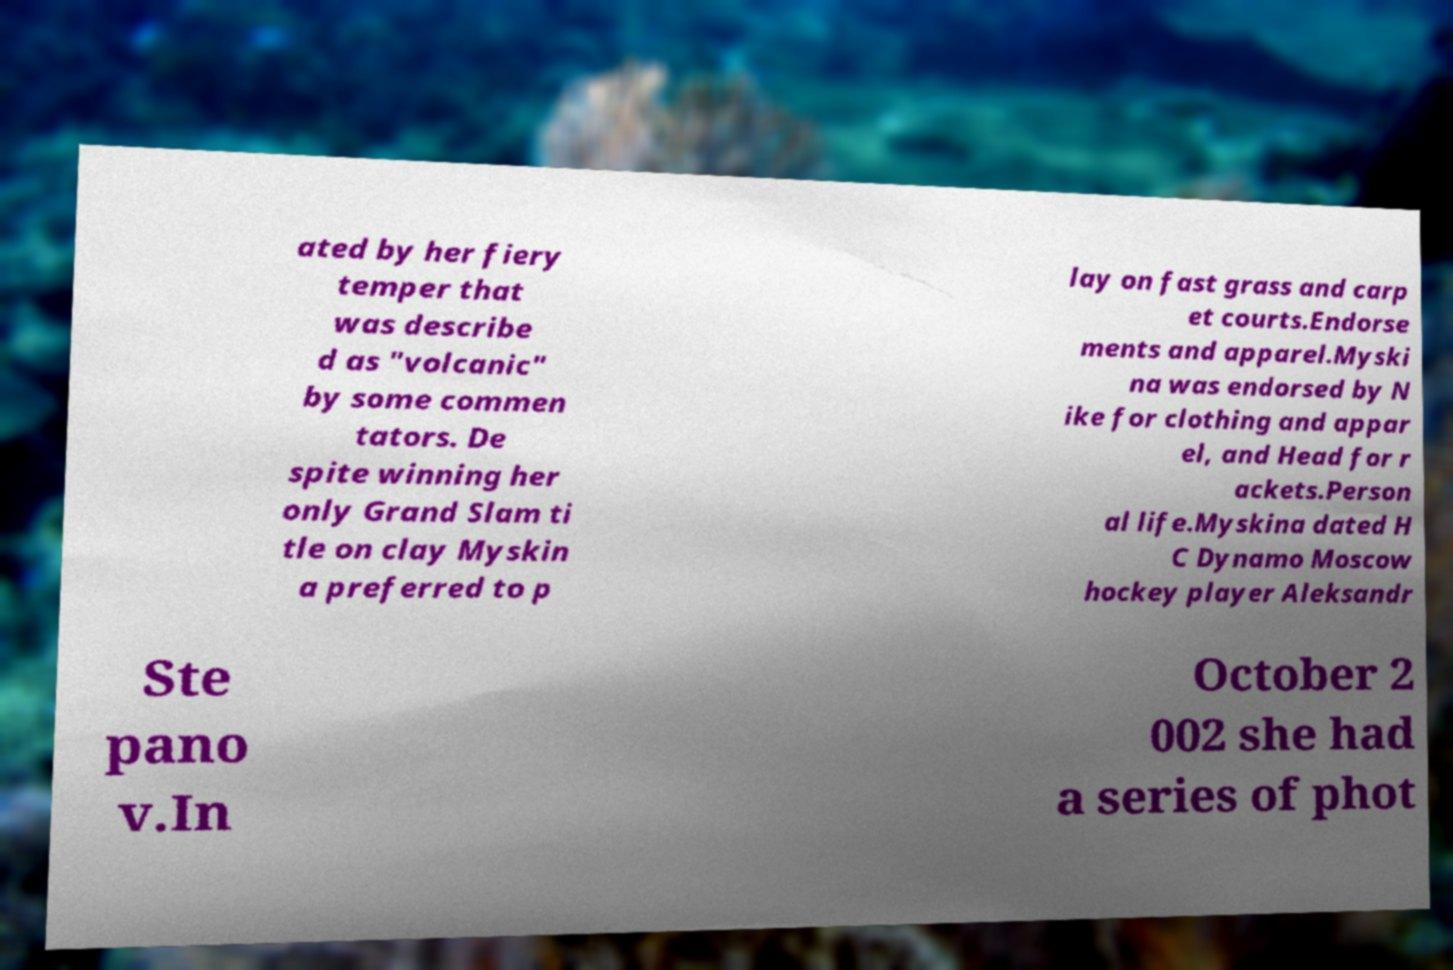Could you assist in decoding the text presented in this image and type it out clearly? ated by her fiery temper that was describe d as "volcanic" by some commen tators. De spite winning her only Grand Slam ti tle on clay Myskin a preferred to p lay on fast grass and carp et courts.Endorse ments and apparel.Myski na was endorsed by N ike for clothing and appar el, and Head for r ackets.Person al life.Myskina dated H C Dynamo Moscow hockey player Aleksandr Ste pano v.In October 2 002 she had a series of phot 